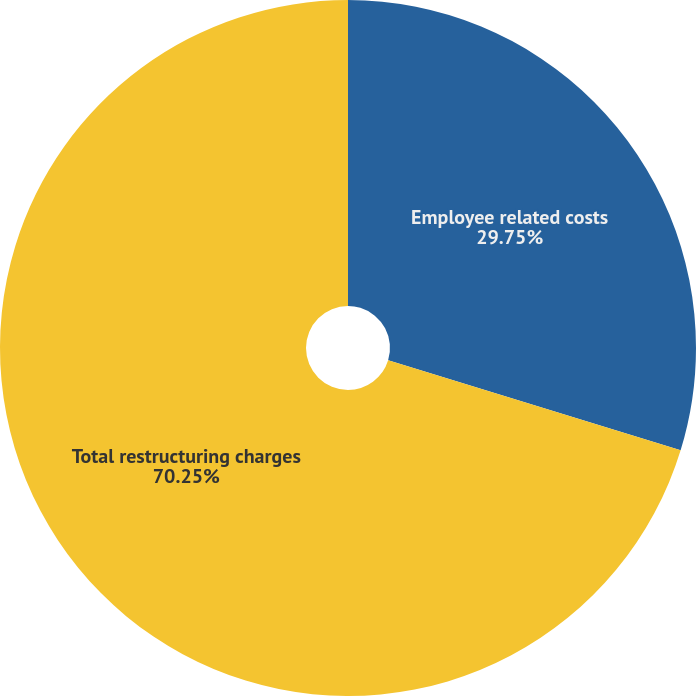Convert chart to OTSL. <chart><loc_0><loc_0><loc_500><loc_500><pie_chart><fcel>Employee related costs<fcel>Total restructuring charges<nl><fcel>29.75%<fcel>70.25%<nl></chart> 